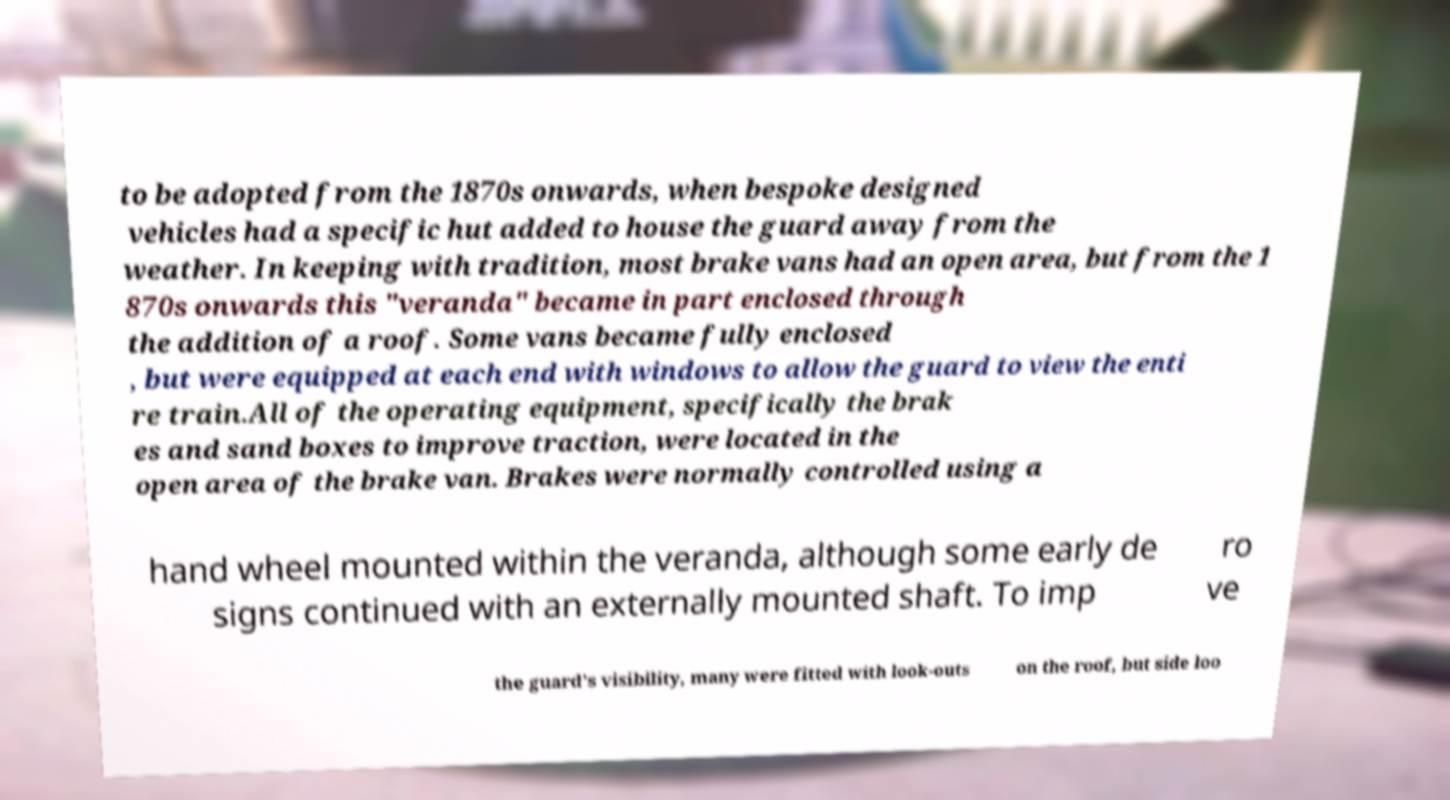Please read and relay the text visible in this image. What does it say? to be adopted from the 1870s onwards, when bespoke designed vehicles had a specific hut added to house the guard away from the weather. In keeping with tradition, most brake vans had an open area, but from the 1 870s onwards this "veranda" became in part enclosed through the addition of a roof. Some vans became fully enclosed , but were equipped at each end with windows to allow the guard to view the enti re train.All of the operating equipment, specifically the brak es and sand boxes to improve traction, were located in the open area of the brake van. Brakes were normally controlled using a hand wheel mounted within the veranda, although some early de signs continued with an externally mounted shaft. To imp ro ve the guard's visibility, many were fitted with look-outs on the roof, but side loo 